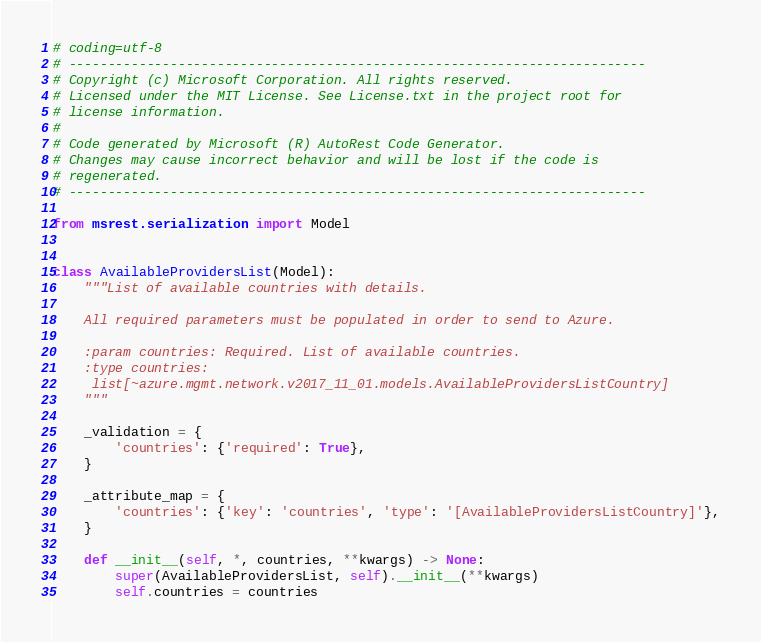<code> <loc_0><loc_0><loc_500><loc_500><_Python_># coding=utf-8
# --------------------------------------------------------------------------
# Copyright (c) Microsoft Corporation. All rights reserved.
# Licensed under the MIT License. See License.txt in the project root for
# license information.
#
# Code generated by Microsoft (R) AutoRest Code Generator.
# Changes may cause incorrect behavior and will be lost if the code is
# regenerated.
# --------------------------------------------------------------------------

from msrest.serialization import Model


class AvailableProvidersList(Model):
    """List of available countries with details.

    All required parameters must be populated in order to send to Azure.

    :param countries: Required. List of available countries.
    :type countries:
     list[~azure.mgmt.network.v2017_11_01.models.AvailableProvidersListCountry]
    """

    _validation = {
        'countries': {'required': True},
    }

    _attribute_map = {
        'countries': {'key': 'countries', 'type': '[AvailableProvidersListCountry]'},
    }

    def __init__(self, *, countries, **kwargs) -> None:
        super(AvailableProvidersList, self).__init__(**kwargs)
        self.countries = countries
</code> 